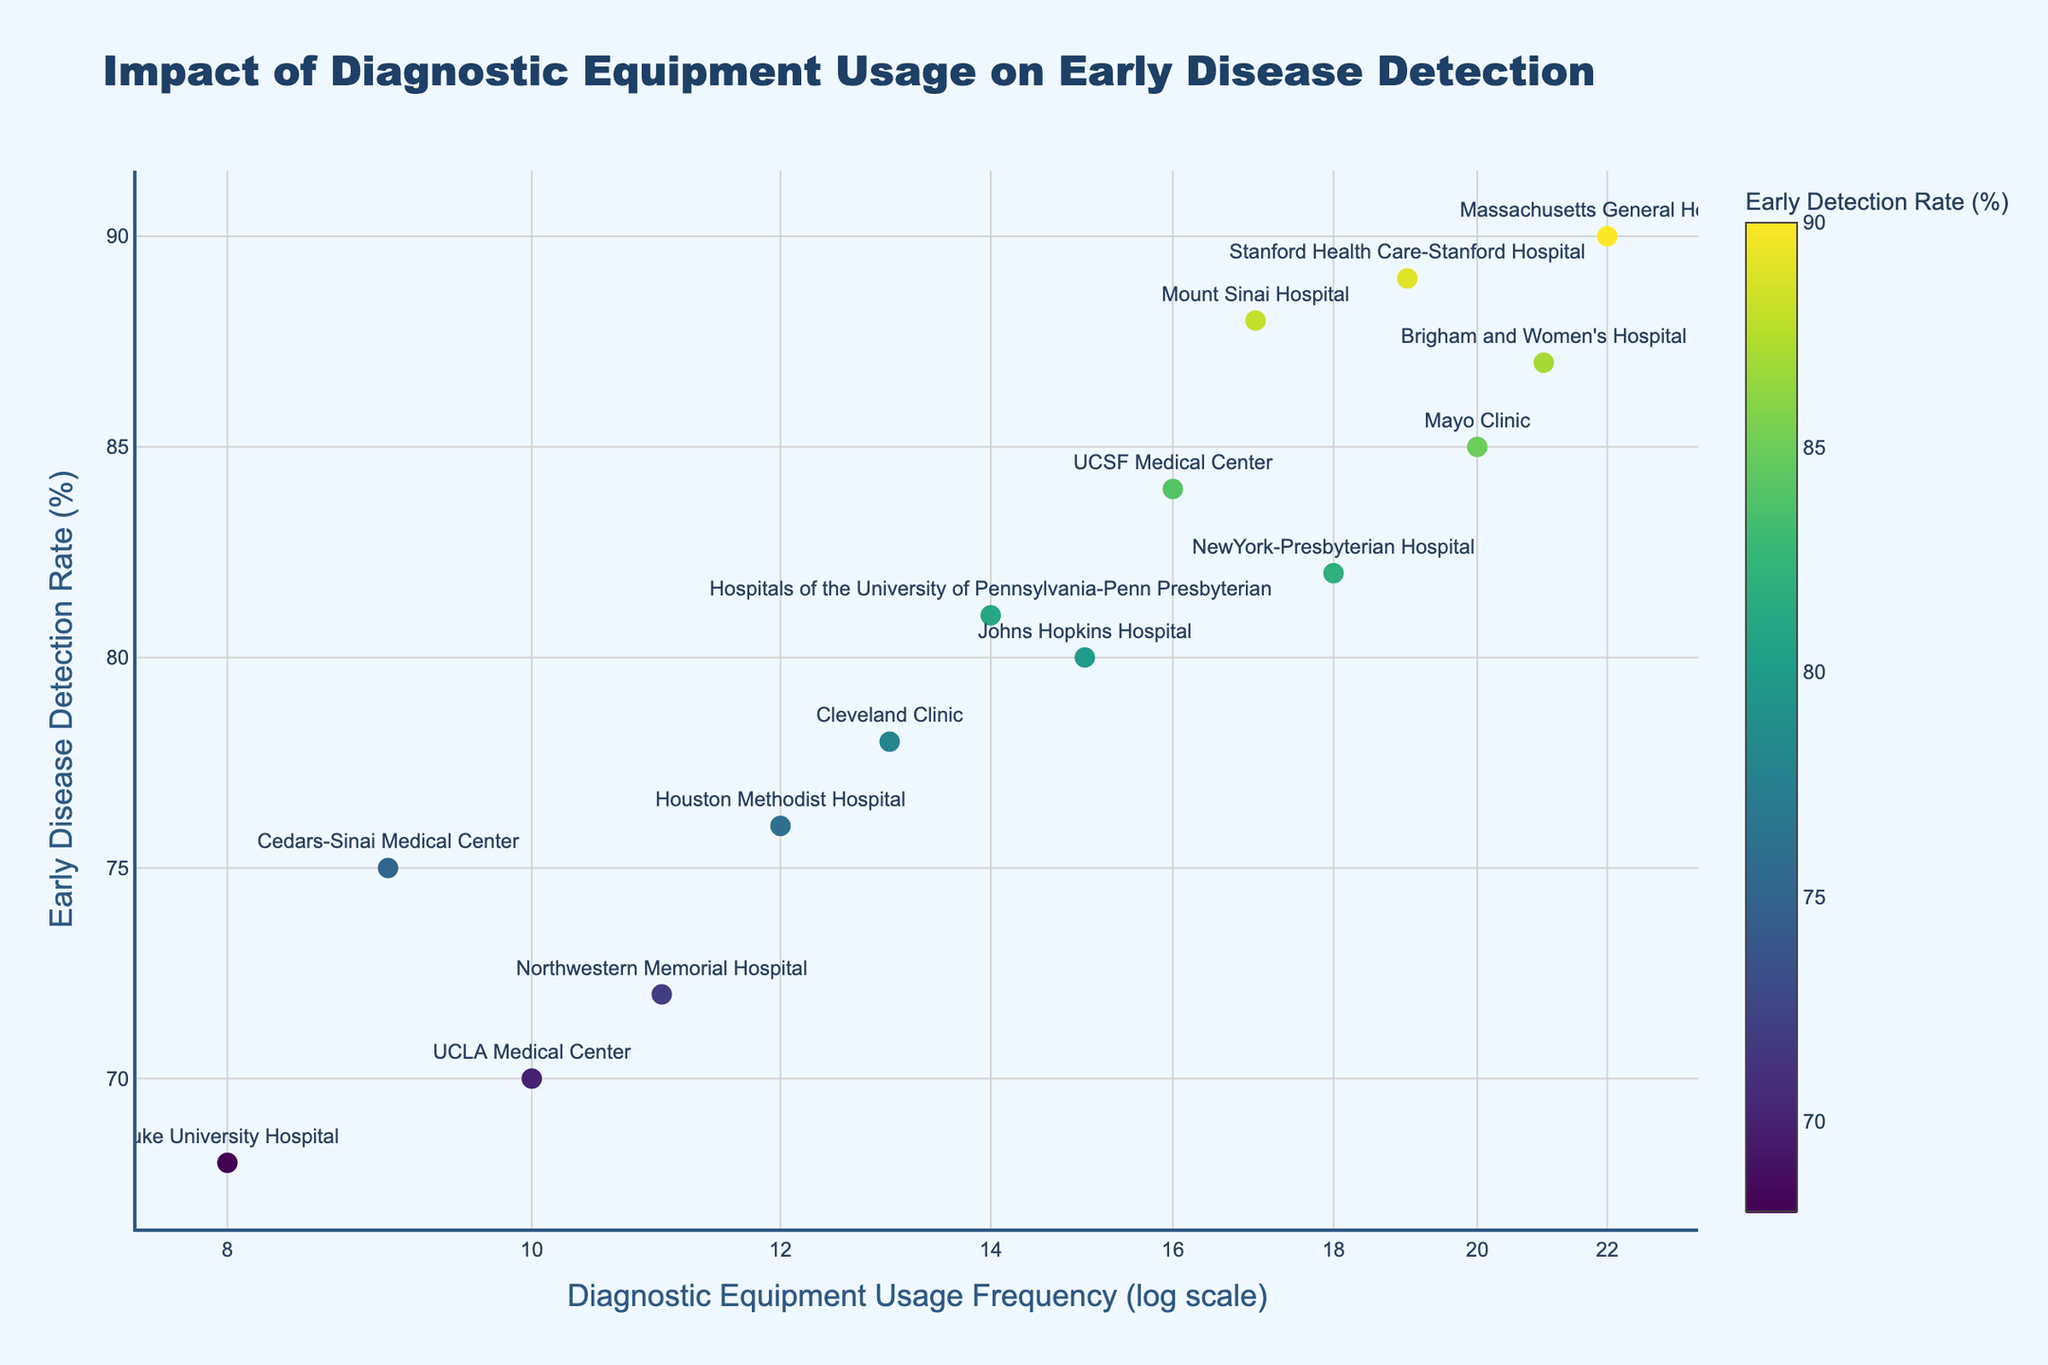What is the title of the plot? The title of the plot is displayed at the top in a distinct, larger font size, usually summarizing the content or purpose of the graph. In this case, the title succinctly indicates what the figure is about.
Answer: Impact of Diagnostic Equipment Usage on Early Disease Detection What axes labels are used in the plot? The axes labels are generally near the respective axes and help identify what each axis represents. They are crucial for understanding the plotted variables. In this figure, the x-axis represents "Diagnostic Equipment Usage Frequency (log scale)," and the y-axis represents "Early Disease Detection Rate (%)".
Answer: Diagnostic Equipment Usage Frequency (log scale), Early Disease Detection Rate (%) Which hospital has the highest early disease detection rate? To find the hospital with the highest early detection rate, locate the point with the highest y-value on the plot. The label next to this point indicates the hospital name.
Answer: Massachusetts General Hospital How many hospitals have a diagnostic equipment usage frequency of 10 or less? We locate all points on the x-axis where the value is 10 or less (considering the log scale), and count them to get the number of hospitals.
Answer: 3 What is the range of early detection rates in the plot? The range is calculated by finding the difference between the highest and lowest early detection rates. Identify the highest y-value and the lowest y-value on the plot, then subtract the two. The highest detection rate is 90%, and the lowest is 68%, so the range is 90 - 68 = 22.
Answer: 22% Is there any apparent relationship between diagnostic equipment usage frequency and early disease detection rate? To determine the relationship, analyze if there is an observable trend in how the points are spread out. If the early detection rate generally increases with usage frequency, there is a positive correlation. Observing the plot, we see that higher frequencies tend to correspond with higher detection rates.
Answer: Yes, there seems to be a positive correlation Which hospital shows the lowest diagnostic equipment usage frequency and what is its early detection rate? Identify the leftmost point on the plot (considering the log scale for x-axis), which represents the lowest usage frequency. Check the label and the corresponding y-value for the detection rate.
Answer: Duke University Hospital, 68% Compare the early detection rates of Mount Sinai Hospital and the Mayo Clinic. Which one has a higher rate? Locate the points representing Mount Sinai Hospital and Mayo Clinic, check their y-values and compare them directly.
Answer: Mount Sinai Hospital What percentage of hospitals have an early detection rate of above 80%? First, count the number of hospitals with an early detection rate above 80%. There are 7 hospitals with detection rates above 80. Next, find the total number of hospitals, which is 15. Calculate the percentage as: (7 / 15) * 100 = 46.67%.
Answer: 46.67% 